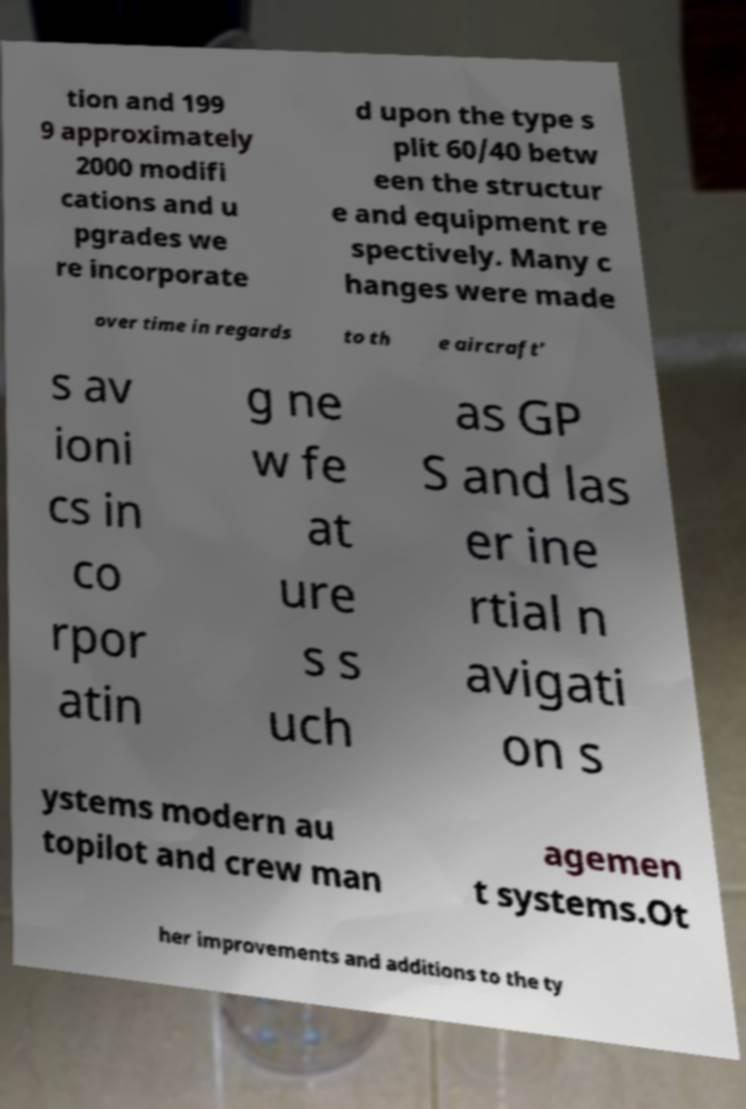For documentation purposes, I need the text within this image transcribed. Could you provide that? tion and 199 9 approximately 2000 modifi cations and u pgrades we re incorporate d upon the type s plit 60/40 betw een the structur e and equipment re spectively. Many c hanges were made over time in regards to th e aircraft' s av ioni cs in co rpor atin g ne w fe at ure s s uch as GP S and las er ine rtial n avigati on s ystems modern au topilot and crew man agemen t systems.Ot her improvements and additions to the ty 